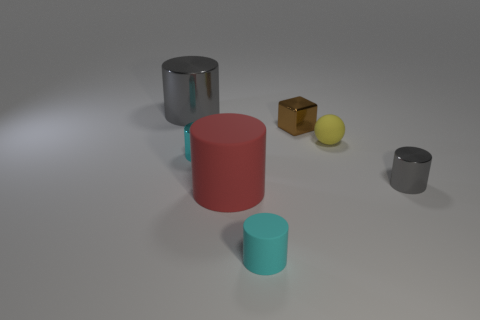How many objects are either tiny cyan cylinders or tiny metallic cylinders?
Provide a short and direct response. 3. Are there fewer red objects than gray objects?
Keep it short and to the point. Yes. The cyan object that is made of the same material as the cube is what size?
Your answer should be very brief. Small. What size is the yellow matte sphere?
Your answer should be very brief. Small. The big gray metallic object is what shape?
Your response must be concise. Cylinder. Is the color of the big cylinder that is right of the small cyan metallic object the same as the sphere?
Keep it short and to the point. No. What size is the cyan rubber object that is the same shape as the big red matte thing?
Offer a terse response. Small. Are there any yellow rubber balls that are to the right of the tiny cyan cylinder in front of the tiny shiny cylinder that is right of the small cyan rubber cylinder?
Your answer should be compact. Yes. What is the material of the cyan thing that is on the right side of the red cylinder?
Provide a short and direct response. Rubber. How many tiny objects are green things or metallic objects?
Give a very brief answer. 3. 